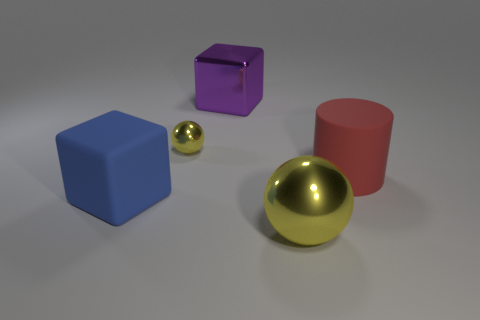Add 2 big metal blocks. How many objects exist? 7 Subtract all cylinders. How many objects are left? 4 Subtract all metal objects. Subtract all big purple shiny blocks. How many objects are left? 1 Add 4 large yellow metal balls. How many large yellow metal balls are left? 5 Add 4 metallic cubes. How many metallic cubes exist? 5 Subtract 1 purple blocks. How many objects are left? 4 